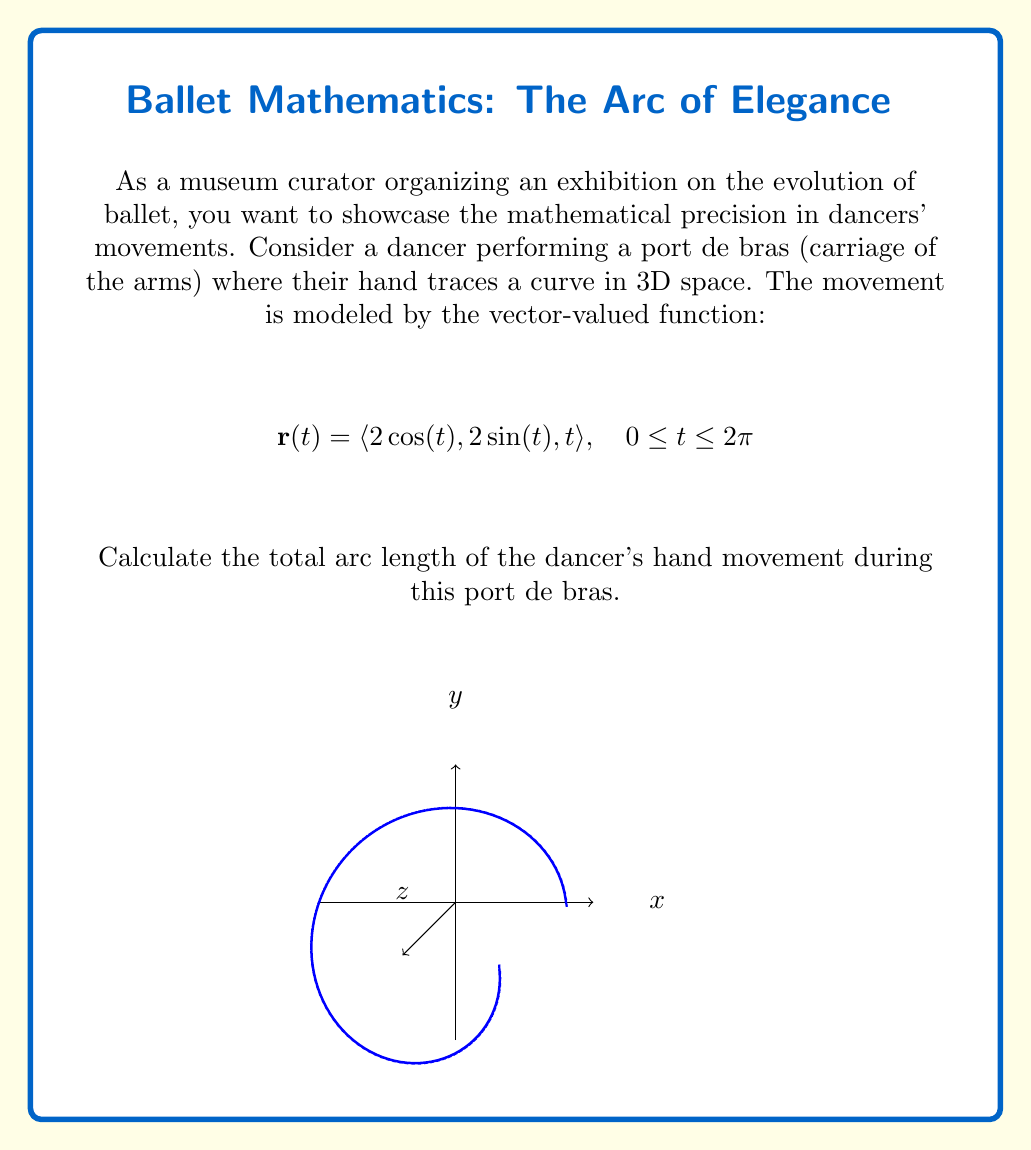Solve this math problem. To calculate the arc length of a vector-valued function, we use the arc length formula:

$$L = \int_a^b \sqrt{\left(\frac{dx}{dt}\right)^2 + \left(\frac{dy}{dt}\right)^2 + \left(\frac{dz}{dt}\right)^2} dt$$

Step 1: Find the derivatives of each component:
$$\frac{dx}{dt} = -2\sin(t)$$
$$\frac{dy}{dt} = 2\cos(t)$$
$$\frac{dz}{dt} = 1$$

Step 2: Square each derivative and add them:
$$\left(\frac{dx}{dt}\right)^2 + \left(\frac{dy}{dt}\right)^2 + \left(\frac{dz}{dt}\right)^2 = (-2\sin(t))^2 + (2\cos(t))^2 + 1^2$$
$$= 4\sin^2(t) + 4\cos^2(t) + 1$$
$$= 4(\sin^2(t) + \cos^2(t)) + 1$$
$$= 4 \cdot 1 + 1 = 5$$

Step 3: Take the square root:
$$\sqrt{\left(\frac{dx}{dt}\right)^2 + \left(\frac{dy}{dt}\right)^2 + \left(\frac{dz}{dt}\right)^2} = \sqrt{5}$$

Step 4: Integrate from 0 to 2π:
$$L = \int_0^{2\pi} \sqrt{5} dt = \sqrt{5} \int_0^{2\pi} dt = \sqrt{5} [t]_0^{2\pi} = 2\pi\sqrt{5}$$

Therefore, the total arc length of the dancer's hand movement during this port de bras is $2\pi\sqrt{5}$.
Answer: $2\pi\sqrt{5}$ 